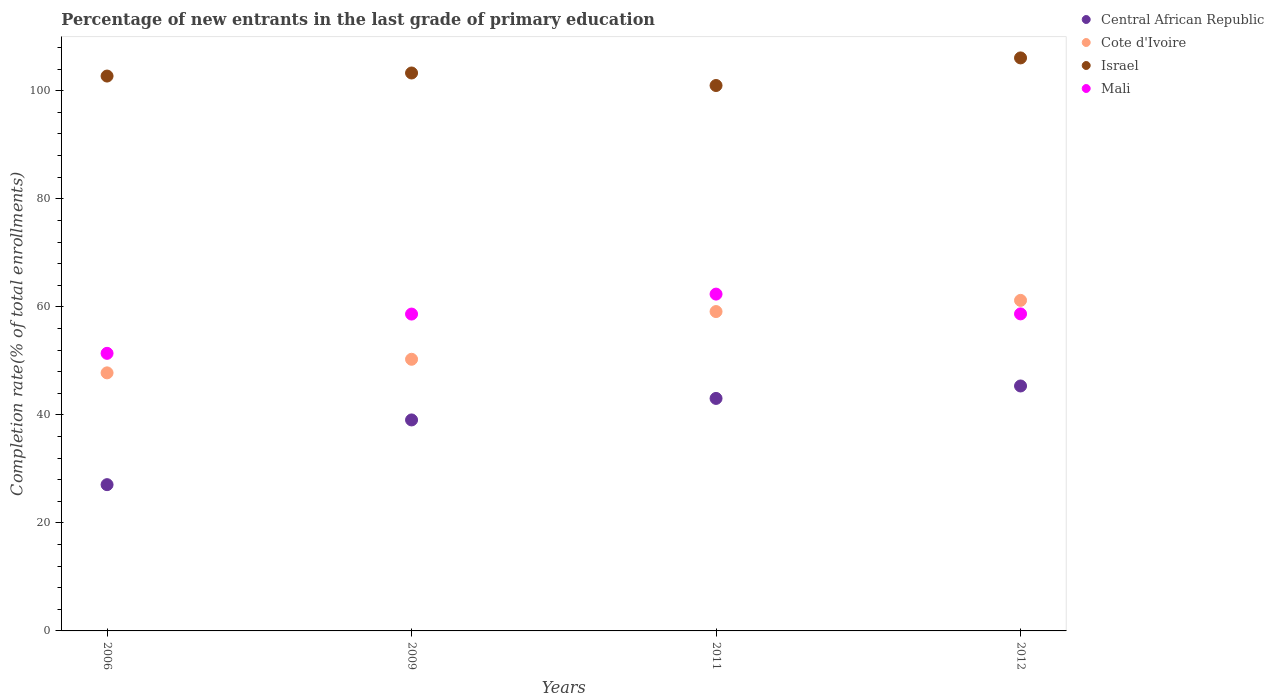How many different coloured dotlines are there?
Provide a short and direct response. 4. Is the number of dotlines equal to the number of legend labels?
Keep it short and to the point. Yes. What is the percentage of new entrants in Central African Republic in 2012?
Your response must be concise. 45.35. Across all years, what is the maximum percentage of new entrants in Cote d'Ivoire?
Keep it short and to the point. 61.2. Across all years, what is the minimum percentage of new entrants in Central African Republic?
Provide a short and direct response. 27.08. What is the total percentage of new entrants in Israel in the graph?
Make the answer very short. 413.08. What is the difference between the percentage of new entrants in Cote d'Ivoire in 2006 and that in 2011?
Your answer should be compact. -11.35. What is the difference between the percentage of new entrants in Israel in 2012 and the percentage of new entrants in Mali in 2009?
Your answer should be compact. 47.42. What is the average percentage of new entrants in Israel per year?
Offer a very short reply. 103.27. In the year 2006, what is the difference between the percentage of new entrants in Central African Republic and percentage of new entrants in Mali?
Offer a terse response. -24.31. What is the ratio of the percentage of new entrants in Central African Republic in 2006 to that in 2009?
Make the answer very short. 0.69. Is the difference between the percentage of new entrants in Central African Republic in 2011 and 2012 greater than the difference between the percentage of new entrants in Mali in 2011 and 2012?
Keep it short and to the point. No. What is the difference between the highest and the second highest percentage of new entrants in Israel?
Provide a short and direct response. 2.79. What is the difference between the highest and the lowest percentage of new entrants in Mali?
Keep it short and to the point. 10.97. Is the sum of the percentage of new entrants in Central African Republic in 2009 and 2011 greater than the maximum percentage of new entrants in Israel across all years?
Provide a succinct answer. No. Is the percentage of new entrants in Cote d'Ivoire strictly greater than the percentage of new entrants in Israel over the years?
Your response must be concise. No. How many years are there in the graph?
Offer a very short reply. 4. Are the values on the major ticks of Y-axis written in scientific E-notation?
Give a very brief answer. No. Does the graph contain any zero values?
Your answer should be very brief. No. Does the graph contain grids?
Provide a succinct answer. No. What is the title of the graph?
Offer a very short reply. Percentage of new entrants in the last grade of primary education. Does "Tonga" appear as one of the legend labels in the graph?
Provide a short and direct response. No. What is the label or title of the X-axis?
Give a very brief answer. Years. What is the label or title of the Y-axis?
Provide a short and direct response. Completion rate(% of total enrollments). What is the Completion rate(% of total enrollments) in Central African Republic in 2006?
Give a very brief answer. 27.08. What is the Completion rate(% of total enrollments) in Cote d'Ivoire in 2006?
Make the answer very short. 47.78. What is the Completion rate(% of total enrollments) in Israel in 2006?
Make the answer very short. 102.73. What is the Completion rate(% of total enrollments) of Mali in 2006?
Your response must be concise. 51.39. What is the Completion rate(% of total enrollments) of Central African Republic in 2009?
Your answer should be compact. 39.06. What is the Completion rate(% of total enrollments) of Cote d'Ivoire in 2009?
Give a very brief answer. 50.29. What is the Completion rate(% of total enrollments) in Israel in 2009?
Offer a very short reply. 103.29. What is the Completion rate(% of total enrollments) of Mali in 2009?
Offer a very short reply. 58.66. What is the Completion rate(% of total enrollments) of Central African Republic in 2011?
Offer a very short reply. 43.04. What is the Completion rate(% of total enrollments) of Cote d'Ivoire in 2011?
Your answer should be very brief. 59.13. What is the Completion rate(% of total enrollments) of Israel in 2011?
Your answer should be very brief. 100.98. What is the Completion rate(% of total enrollments) of Mali in 2011?
Ensure brevity in your answer.  62.36. What is the Completion rate(% of total enrollments) in Central African Republic in 2012?
Give a very brief answer. 45.35. What is the Completion rate(% of total enrollments) of Cote d'Ivoire in 2012?
Offer a very short reply. 61.2. What is the Completion rate(% of total enrollments) in Israel in 2012?
Make the answer very short. 106.08. What is the Completion rate(% of total enrollments) of Mali in 2012?
Offer a very short reply. 58.69. Across all years, what is the maximum Completion rate(% of total enrollments) of Central African Republic?
Your response must be concise. 45.35. Across all years, what is the maximum Completion rate(% of total enrollments) of Cote d'Ivoire?
Ensure brevity in your answer.  61.2. Across all years, what is the maximum Completion rate(% of total enrollments) in Israel?
Provide a short and direct response. 106.08. Across all years, what is the maximum Completion rate(% of total enrollments) of Mali?
Ensure brevity in your answer.  62.36. Across all years, what is the minimum Completion rate(% of total enrollments) of Central African Republic?
Give a very brief answer. 27.08. Across all years, what is the minimum Completion rate(% of total enrollments) of Cote d'Ivoire?
Make the answer very short. 47.78. Across all years, what is the minimum Completion rate(% of total enrollments) in Israel?
Your answer should be very brief. 100.98. Across all years, what is the minimum Completion rate(% of total enrollments) of Mali?
Provide a short and direct response. 51.39. What is the total Completion rate(% of total enrollments) of Central African Republic in the graph?
Your answer should be compact. 154.53. What is the total Completion rate(% of total enrollments) of Cote d'Ivoire in the graph?
Your answer should be compact. 218.39. What is the total Completion rate(% of total enrollments) of Israel in the graph?
Make the answer very short. 413.08. What is the total Completion rate(% of total enrollments) in Mali in the graph?
Your answer should be very brief. 231.1. What is the difference between the Completion rate(% of total enrollments) in Central African Republic in 2006 and that in 2009?
Offer a terse response. -11.98. What is the difference between the Completion rate(% of total enrollments) of Cote d'Ivoire in 2006 and that in 2009?
Provide a short and direct response. -2.51. What is the difference between the Completion rate(% of total enrollments) in Israel in 2006 and that in 2009?
Give a very brief answer. -0.57. What is the difference between the Completion rate(% of total enrollments) of Mali in 2006 and that in 2009?
Provide a short and direct response. -7.27. What is the difference between the Completion rate(% of total enrollments) in Central African Republic in 2006 and that in 2011?
Provide a short and direct response. -15.96. What is the difference between the Completion rate(% of total enrollments) in Cote d'Ivoire in 2006 and that in 2011?
Make the answer very short. -11.35. What is the difference between the Completion rate(% of total enrollments) in Israel in 2006 and that in 2011?
Offer a terse response. 1.75. What is the difference between the Completion rate(% of total enrollments) in Mali in 2006 and that in 2011?
Your response must be concise. -10.97. What is the difference between the Completion rate(% of total enrollments) in Central African Republic in 2006 and that in 2012?
Your answer should be very brief. -18.27. What is the difference between the Completion rate(% of total enrollments) of Cote d'Ivoire in 2006 and that in 2012?
Give a very brief answer. -13.42. What is the difference between the Completion rate(% of total enrollments) in Israel in 2006 and that in 2012?
Offer a very short reply. -3.36. What is the difference between the Completion rate(% of total enrollments) in Mali in 2006 and that in 2012?
Provide a short and direct response. -7.3. What is the difference between the Completion rate(% of total enrollments) of Central African Republic in 2009 and that in 2011?
Ensure brevity in your answer.  -3.98. What is the difference between the Completion rate(% of total enrollments) of Cote d'Ivoire in 2009 and that in 2011?
Make the answer very short. -8.83. What is the difference between the Completion rate(% of total enrollments) of Israel in 2009 and that in 2011?
Offer a very short reply. 2.32. What is the difference between the Completion rate(% of total enrollments) in Mali in 2009 and that in 2011?
Your answer should be very brief. -3.7. What is the difference between the Completion rate(% of total enrollments) in Central African Republic in 2009 and that in 2012?
Offer a terse response. -6.29. What is the difference between the Completion rate(% of total enrollments) in Cote d'Ivoire in 2009 and that in 2012?
Make the answer very short. -10.9. What is the difference between the Completion rate(% of total enrollments) of Israel in 2009 and that in 2012?
Offer a terse response. -2.79. What is the difference between the Completion rate(% of total enrollments) of Mali in 2009 and that in 2012?
Your answer should be compact. -0.03. What is the difference between the Completion rate(% of total enrollments) in Central African Republic in 2011 and that in 2012?
Make the answer very short. -2.3. What is the difference between the Completion rate(% of total enrollments) in Cote d'Ivoire in 2011 and that in 2012?
Offer a very short reply. -2.07. What is the difference between the Completion rate(% of total enrollments) in Israel in 2011 and that in 2012?
Offer a terse response. -5.11. What is the difference between the Completion rate(% of total enrollments) of Mali in 2011 and that in 2012?
Your response must be concise. 3.66. What is the difference between the Completion rate(% of total enrollments) in Central African Republic in 2006 and the Completion rate(% of total enrollments) in Cote d'Ivoire in 2009?
Keep it short and to the point. -23.21. What is the difference between the Completion rate(% of total enrollments) of Central African Republic in 2006 and the Completion rate(% of total enrollments) of Israel in 2009?
Keep it short and to the point. -76.21. What is the difference between the Completion rate(% of total enrollments) in Central African Republic in 2006 and the Completion rate(% of total enrollments) in Mali in 2009?
Make the answer very short. -31.58. What is the difference between the Completion rate(% of total enrollments) in Cote d'Ivoire in 2006 and the Completion rate(% of total enrollments) in Israel in 2009?
Your answer should be compact. -55.52. What is the difference between the Completion rate(% of total enrollments) of Cote d'Ivoire in 2006 and the Completion rate(% of total enrollments) of Mali in 2009?
Offer a terse response. -10.88. What is the difference between the Completion rate(% of total enrollments) in Israel in 2006 and the Completion rate(% of total enrollments) in Mali in 2009?
Provide a short and direct response. 44.07. What is the difference between the Completion rate(% of total enrollments) of Central African Republic in 2006 and the Completion rate(% of total enrollments) of Cote d'Ivoire in 2011?
Offer a very short reply. -32.05. What is the difference between the Completion rate(% of total enrollments) in Central African Republic in 2006 and the Completion rate(% of total enrollments) in Israel in 2011?
Provide a short and direct response. -73.9. What is the difference between the Completion rate(% of total enrollments) of Central African Republic in 2006 and the Completion rate(% of total enrollments) of Mali in 2011?
Provide a short and direct response. -35.28. What is the difference between the Completion rate(% of total enrollments) in Cote d'Ivoire in 2006 and the Completion rate(% of total enrollments) in Israel in 2011?
Make the answer very short. -53.2. What is the difference between the Completion rate(% of total enrollments) in Cote d'Ivoire in 2006 and the Completion rate(% of total enrollments) in Mali in 2011?
Provide a short and direct response. -14.58. What is the difference between the Completion rate(% of total enrollments) of Israel in 2006 and the Completion rate(% of total enrollments) of Mali in 2011?
Offer a very short reply. 40.37. What is the difference between the Completion rate(% of total enrollments) of Central African Republic in 2006 and the Completion rate(% of total enrollments) of Cote d'Ivoire in 2012?
Provide a succinct answer. -34.12. What is the difference between the Completion rate(% of total enrollments) in Central African Republic in 2006 and the Completion rate(% of total enrollments) in Israel in 2012?
Ensure brevity in your answer.  -79.01. What is the difference between the Completion rate(% of total enrollments) of Central African Republic in 2006 and the Completion rate(% of total enrollments) of Mali in 2012?
Your answer should be compact. -31.61. What is the difference between the Completion rate(% of total enrollments) of Cote d'Ivoire in 2006 and the Completion rate(% of total enrollments) of Israel in 2012?
Provide a short and direct response. -58.31. What is the difference between the Completion rate(% of total enrollments) of Cote d'Ivoire in 2006 and the Completion rate(% of total enrollments) of Mali in 2012?
Keep it short and to the point. -10.92. What is the difference between the Completion rate(% of total enrollments) of Israel in 2006 and the Completion rate(% of total enrollments) of Mali in 2012?
Keep it short and to the point. 44.03. What is the difference between the Completion rate(% of total enrollments) of Central African Republic in 2009 and the Completion rate(% of total enrollments) of Cote d'Ivoire in 2011?
Provide a succinct answer. -20.06. What is the difference between the Completion rate(% of total enrollments) in Central African Republic in 2009 and the Completion rate(% of total enrollments) in Israel in 2011?
Provide a short and direct response. -61.91. What is the difference between the Completion rate(% of total enrollments) in Central African Republic in 2009 and the Completion rate(% of total enrollments) in Mali in 2011?
Give a very brief answer. -23.29. What is the difference between the Completion rate(% of total enrollments) of Cote d'Ivoire in 2009 and the Completion rate(% of total enrollments) of Israel in 2011?
Offer a terse response. -50.68. What is the difference between the Completion rate(% of total enrollments) in Cote d'Ivoire in 2009 and the Completion rate(% of total enrollments) in Mali in 2011?
Your answer should be very brief. -12.07. What is the difference between the Completion rate(% of total enrollments) in Israel in 2009 and the Completion rate(% of total enrollments) in Mali in 2011?
Ensure brevity in your answer.  40.94. What is the difference between the Completion rate(% of total enrollments) of Central African Republic in 2009 and the Completion rate(% of total enrollments) of Cote d'Ivoire in 2012?
Make the answer very short. -22.13. What is the difference between the Completion rate(% of total enrollments) in Central African Republic in 2009 and the Completion rate(% of total enrollments) in Israel in 2012?
Keep it short and to the point. -67.02. What is the difference between the Completion rate(% of total enrollments) of Central African Republic in 2009 and the Completion rate(% of total enrollments) of Mali in 2012?
Your answer should be compact. -19.63. What is the difference between the Completion rate(% of total enrollments) in Cote d'Ivoire in 2009 and the Completion rate(% of total enrollments) in Israel in 2012?
Your response must be concise. -55.79. What is the difference between the Completion rate(% of total enrollments) of Cote d'Ivoire in 2009 and the Completion rate(% of total enrollments) of Mali in 2012?
Offer a terse response. -8.4. What is the difference between the Completion rate(% of total enrollments) in Israel in 2009 and the Completion rate(% of total enrollments) in Mali in 2012?
Offer a very short reply. 44.6. What is the difference between the Completion rate(% of total enrollments) of Central African Republic in 2011 and the Completion rate(% of total enrollments) of Cote d'Ivoire in 2012?
Your answer should be very brief. -18.15. What is the difference between the Completion rate(% of total enrollments) of Central African Republic in 2011 and the Completion rate(% of total enrollments) of Israel in 2012?
Your answer should be very brief. -63.04. What is the difference between the Completion rate(% of total enrollments) in Central African Republic in 2011 and the Completion rate(% of total enrollments) in Mali in 2012?
Your response must be concise. -15.65. What is the difference between the Completion rate(% of total enrollments) of Cote d'Ivoire in 2011 and the Completion rate(% of total enrollments) of Israel in 2012?
Give a very brief answer. -46.96. What is the difference between the Completion rate(% of total enrollments) of Cote d'Ivoire in 2011 and the Completion rate(% of total enrollments) of Mali in 2012?
Provide a succinct answer. 0.43. What is the difference between the Completion rate(% of total enrollments) of Israel in 2011 and the Completion rate(% of total enrollments) of Mali in 2012?
Your response must be concise. 42.28. What is the average Completion rate(% of total enrollments) of Central African Republic per year?
Provide a succinct answer. 38.63. What is the average Completion rate(% of total enrollments) of Cote d'Ivoire per year?
Provide a short and direct response. 54.6. What is the average Completion rate(% of total enrollments) of Israel per year?
Make the answer very short. 103.27. What is the average Completion rate(% of total enrollments) of Mali per year?
Keep it short and to the point. 57.77. In the year 2006, what is the difference between the Completion rate(% of total enrollments) of Central African Republic and Completion rate(% of total enrollments) of Cote d'Ivoire?
Keep it short and to the point. -20.7. In the year 2006, what is the difference between the Completion rate(% of total enrollments) in Central African Republic and Completion rate(% of total enrollments) in Israel?
Your answer should be very brief. -75.65. In the year 2006, what is the difference between the Completion rate(% of total enrollments) of Central African Republic and Completion rate(% of total enrollments) of Mali?
Give a very brief answer. -24.31. In the year 2006, what is the difference between the Completion rate(% of total enrollments) of Cote d'Ivoire and Completion rate(% of total enrollments) of Israel?
Your response must be concise. -54.95. In the year 2006, what is the difference between the Completion rate(% of total enrollments) of Cote d'Ivoire and Completion rate(% of total enrollments) of Mali?
Provide a short and direct response. -3.61. In the year 2006, what is the difference between the Completion rate(% of total enrollments) in Israel and Completion rate(% of total enrollments) in Mali?
Give a very brief answer. 51.34. In the year 2009, what is the difference between the Completion rate(% of total enrollments) of Central African Republic and Completion rate(% of total enrollments) of Cote d'Ivoire?
Give a very brief answer. -11.23. In the year 2009, what is the difference between the Completion rate(% of total enrollments) in Central African Republic and Completion rate(% of total enrollments) in Israel?
Offer a very short reply. -64.23. In the year 2009, what is the difference between the Completion rate(% of total enrollments) of Central African Republic and Completion rate(% of total enrollments) of Mali?
Offer a terse response. -19.6. In the year 2009, what is the difference between the Completion rate(% of total enrollments) of Cote d'Ivoire and Completion rate(% of total enrollments) of Israel?
Give a very brief answer. -53. In the year 2009, what is the difference between the Completion rate(% of total enrollments) of Cote d'Ivoire and Completion rate(% of total enrollments) of Mali?
Provide a succinct answer. -8.37. In the year 2009, what is the difference between the Completion rate(% of total enrollments) of Israel and Completion rate(% of total enrollments) of Mali?
Offer a terse response. 44.63. In the year 2011, what is the difference between the Completion rate(% of total enrollments) of Central African Republic and Completion rate(% of total enrollments) of Cote d'Ivoire?
Give a very brief answer. -16.08. In the year 2011, what is the difference between the Completion rate(% of total enrollments) in Central African Republic and Completion rate(% of total enrollments) in Israel?
Make the answer very short. -57.93. In the year 2011, what is the difference between the Completion rate(% of total enrollments) in Central African Republic and Completion rate(% of total enrollments) in Mali?
Make the answer very short. -19.31. In the year 2011, what is the difference between the Completion rate(% of total enrollments) in Cote d'Ivoire and Completion rate(% of total enrollments) in Israel?
Offer a terse response. -41.85. In the year 2011, what is the difference between the Completion rate(% of total enrollments) in Cote d'Ivoire and Completion rate(% of total enrollments) in Mali?
Ensure brevity in your answer.  -3.23. In the year 2011, what is the difference between the Completion rate(% of total enrollments) in Israel and Completion rate(% of total enrollments) in Mali?
Give a very brief answer. 38.62. In the year 2012, what is the difference between the Completion rate(% of total enrollments) in Central African Republic and Completion rate(% of total enrollments) in Cote d'Ivoire?
Make the answer very short. -15.85. In the year 2012, what is the difference between the Completion rate(% of total enrollments) of Central African Republic and Completion rate(% of total enrollments) of Israel?
Provide a succinct answer. -60.74. In the year 2012, what is the difference between the Completion rate(% of total enrollments) in Central African Republic and Completion rate(% of total enrollments) in Mali?
Offer a very short reply. -13.34. In the year 2012, what is the difference between the Completion rate(% of total enrollments) in Cote d'Ivoire and Completion rate(% of total enrollments) in Israel?
Your response must be concise. -44.89. In the year 2012, what is the difference between the Completion rate(% of total enrollments) in Cote d'Ivoire and Completion rate(% of total enrollments) in Mali?
Your answer should be very brief. 2.5. In the year 2012, what is the difference between the Completion rate(% of total enrollments) in Israel and Completion rate(% of total enrollments) in Mali?
Your answer should be very brief. 47.39. What is the ratio of the Completion rate(% of total enrollments) in Central African Republic in 2006 to that in 2009?
Give a very brief answer. 0.69. What is the ratio of the Completion rate(% of total enrollments) in Cote d'Ivoire in 2006 to that in 2009?
Offer a terse response. 0.95. What is the ratio of the Completion rate(% of total enrollments) of Mali in 2006 to that in 2009?
Your answer should be compact. 0.88. What is the ratio of the Completion rate(% of total enrollments) of Central African Republic in 2006 to that in 2011?
Make the answer very short. 0.63. What is the ratio of the Completion rate(% of total enrollments) of Cote d'Ivoire in 2006 to that in 2011?
Keep it short and to the point. 0.81. What is the ratio of the Completion rate(% of total enrollments) of Israel in 2006 to that in 2011?
Offer a terse response. 1.02. What is the ratio of the Completion rate(% of total enrollments) in Mali in 2006 to that in 2011?
Make the answer very short. 0.82. What is the ratio of the Completion rate(% of total enrollments) in Central African Republic in 2006 to that in 2012?
Provide a succinct answer. 0.6. What is the ratio of the Completion rate(% of total enrollments) in Cote d'Ivoire in 2006 to that in 2012?
Give a very brief answer. 0.78. What is the ratio of the Completion rate(% of total enrollments) of Israel in 2006 to that in 2012?
Give a very brief answer. 0.97. What is the ratio of the Completion rate(% of total enrollments) of Mali in 2006 to that in 2012?
Your answer should be compact. 0.88. What is the ratio of the Completion rate(% of total enrollments) of Central African Republic in 2009 to that in 2011?
Ensure brevity in your answer.  0.91. What is the ratio of the Completion rate(% of total enrollments) in Cote d'Ivoire in 2009 to that in 2011?
Offer a very short reply. 0.85. What is the ratio of the Completion rate(% of total enrollments) in Israel in 2009 to that in 2011?
Offer a very short reply. 1.02. What is the ratio of the Completion rate(% of total enrollments) of Mali in 2009 to that in 2011?
Offer a very short reply. 0.94. What is the ratio of the Completion rate(% of total enrollments) of Central African Republic in 2009 to that in 2012?
Offer a terse response. 0.86. What is the ratio of the Completion rate(% of total enrollments) in Cote d'Ivoire in 2009 to that in 2012?
Your answer should be compact. 0.82. What is the ratio of the Completion rate(% of total enrollments) in Israel in 2009 to that in 2012?
Provide a succinct answer. 0.97. What is the ratio of the Completion rate(% of total enrollments) of Mali in 2009 to that in 2012?
Give a very brief answer. 1. What is the ratio of the Completion rate(% of total enrollments) of Central African Republic in 2011 to that in 2012?
Your answer should be compact. 0.95. What is the ratio of the Completion rate(% of total enrollments) in Cote d'Ivoire in 2011 to that in 2012?
Offer a very short reply. 0.97. What is the ratio of the Completion rate(% of total enrollments) in Israel in 2011 to that in 2012?
Keep it short and to the point. 0.95. What is the ratio of the Completion rate(% of total enrollments) of Mali in 2011 to that in 2012?
Ensure brevity in your answer.  1.06. What is the difference between the highest and the second highest Completion rate(% of total enrollments) in Central African Republic?
Give a very brief answer. 2.3. What is the difference between the highest and the second highest Completion rate(% of total enrollments) of Cote d'Ivoire?
Offer a very short reply. 2.07. What is the difference between the highest and the second highest Completion rate(% of total enrollments) in Israel?
Provide a short and direct response. 2.79. What is the difference between the highest and the second highest Completion rate(% of total enrollments) in Mali?
Ensure brevity in your answer.  3.66. What is the difference between the highest and the lowest Completion rate(% of total enrollments) in Central African Republic?
Your answer should be compact. 18.27. What is the difference between the highest and the lowest Completion rate(% of total enrollments) in Cote d'Ivoire?
Ensure brevity in your answer.  13.42. What is the difference between the highest and the lowest Completion rate(% of total enrollments) in Israel?
Offer a very short reply. 5.11. What is the difference between the highest and the lowest Completion rate(% of total enrollments) in Mali?
Provide a succinct answer. 10.97. 